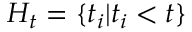Convert formula to latex. <formula><loc_0><loc_0><loc_500><loc_500>H _ { t } = \{ t _ { i } | t _ { i } < t \}</formula> 